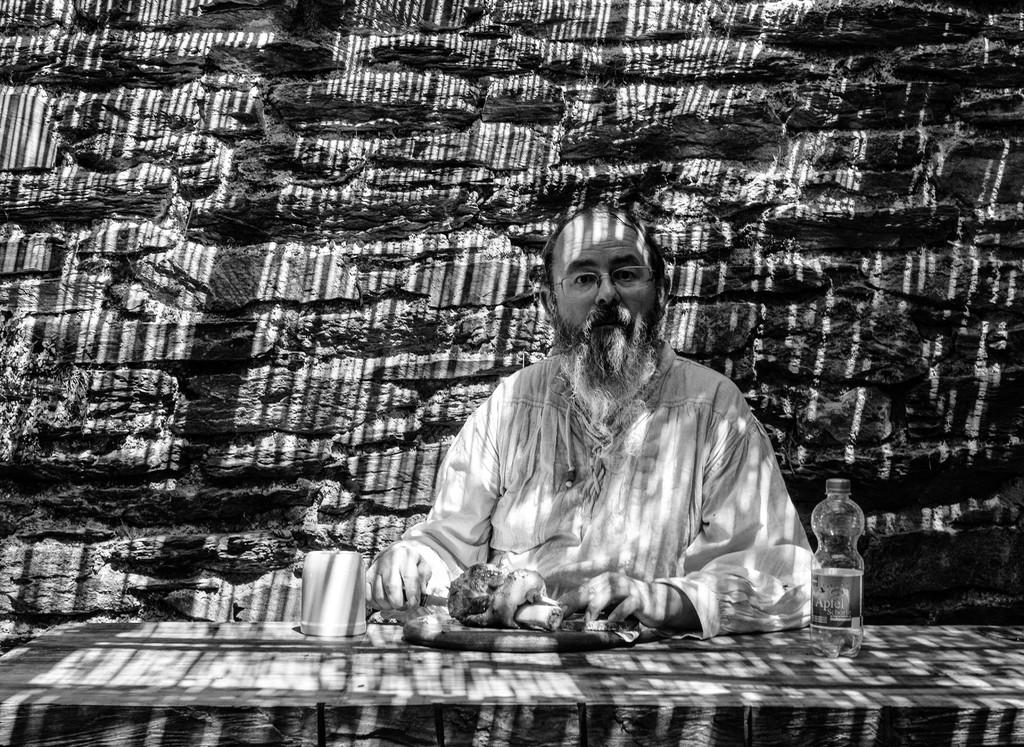What is the man in the image doing? The man is sitting in the image. What is placed in front of the man? There is food in front of the man. What can be seen on the table in the image? There is a bottle on the table. What is visible in the background of the image? There is a wall in the background of the image. What is the value of the cave in the image? There is no cave present in the image, so it is not possible to determine its value. 